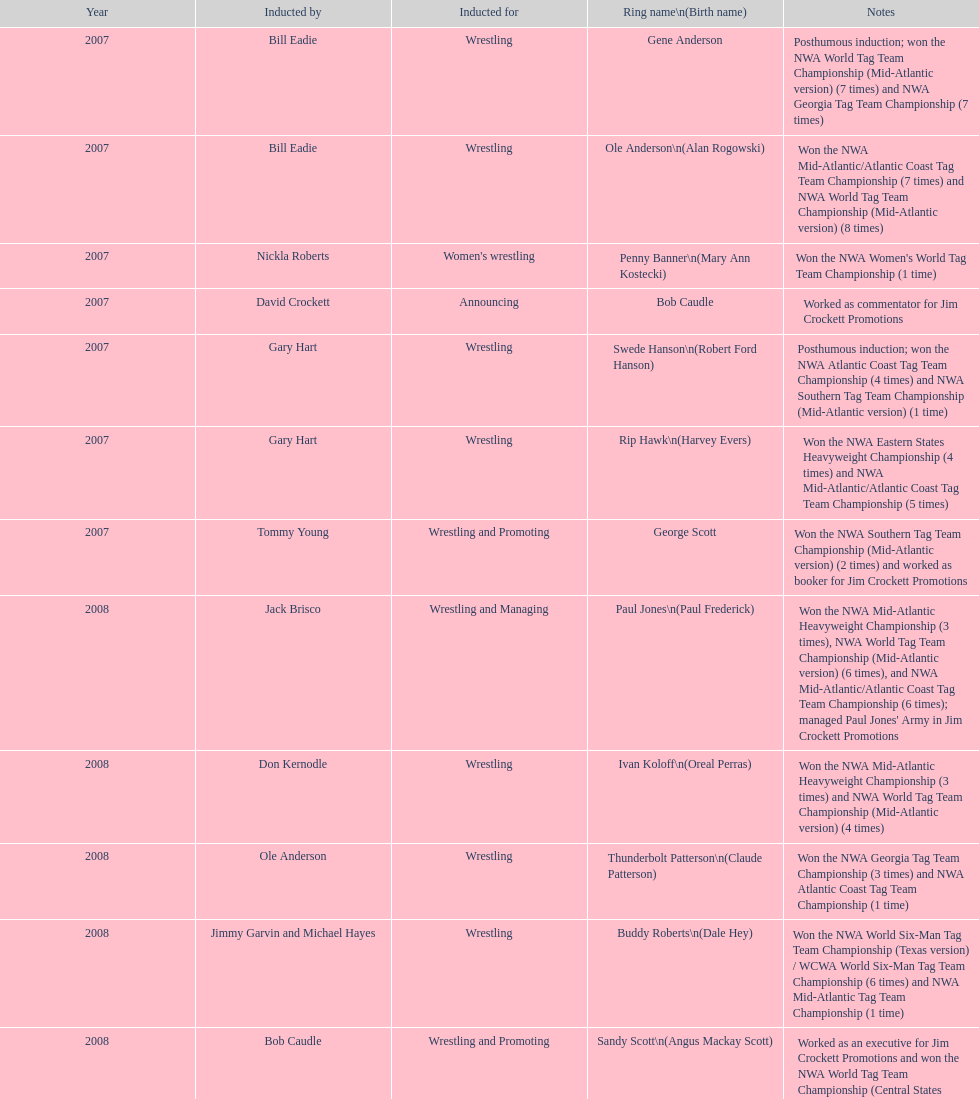How many members were inducted for announcing? 2. 